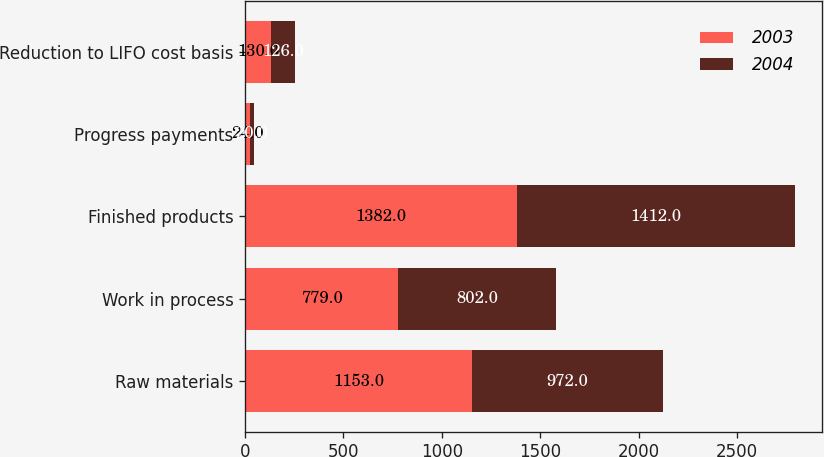Convert chart. <chart><loc_0><loc_0><loc_500><loc_500><stacked_bar_chart><ecel><fcel>Raw materials<fcel>Work in process<fcel>Finished products<fcel>Progress payments<fcel>Reduction to LIFO cost basis<nl><fcel>2003<fcel>1153<fcel>779<fcel>1382<fcel>24<fcel>130<nl><fcel>2004<fcel>972<fcel>802<fcel>1412<fcel>20<fcel>126<nl></chart> 